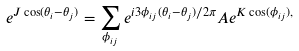Convert formula to latex. <formula><loc_0><loc_0><loc_500><loc_500>e ^ { J \cos ( \theta _ { i } - \theta _ { j } ) } = \sum _ { \phi _ { i j } } e ^ { i 3 \phi _ { i j } ( \theta _ { i } - \theta _ { j } ) / 2 \pi } A e ^ { K \cos ( \phi _ { i j } ) , }</formula> 